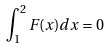<formula> <loc_0><loc_0><loc_500><loc_500>\int _ { 1 } ^ { 2 } F ( x ) d x = 0</formula> 